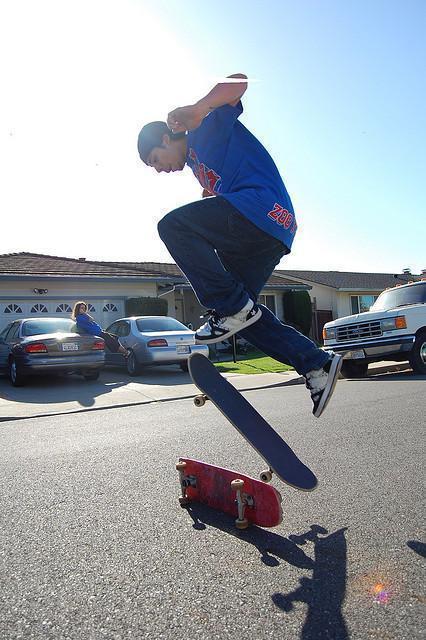What type of skateboarding would this be considered?
Select the accurate answer and provide explanation: 'Answer: answer
Rationale: rationale.'
Options: Park, street, vert, big air. Answer: street.
Rationale: The person is skating near cars in driveways. 